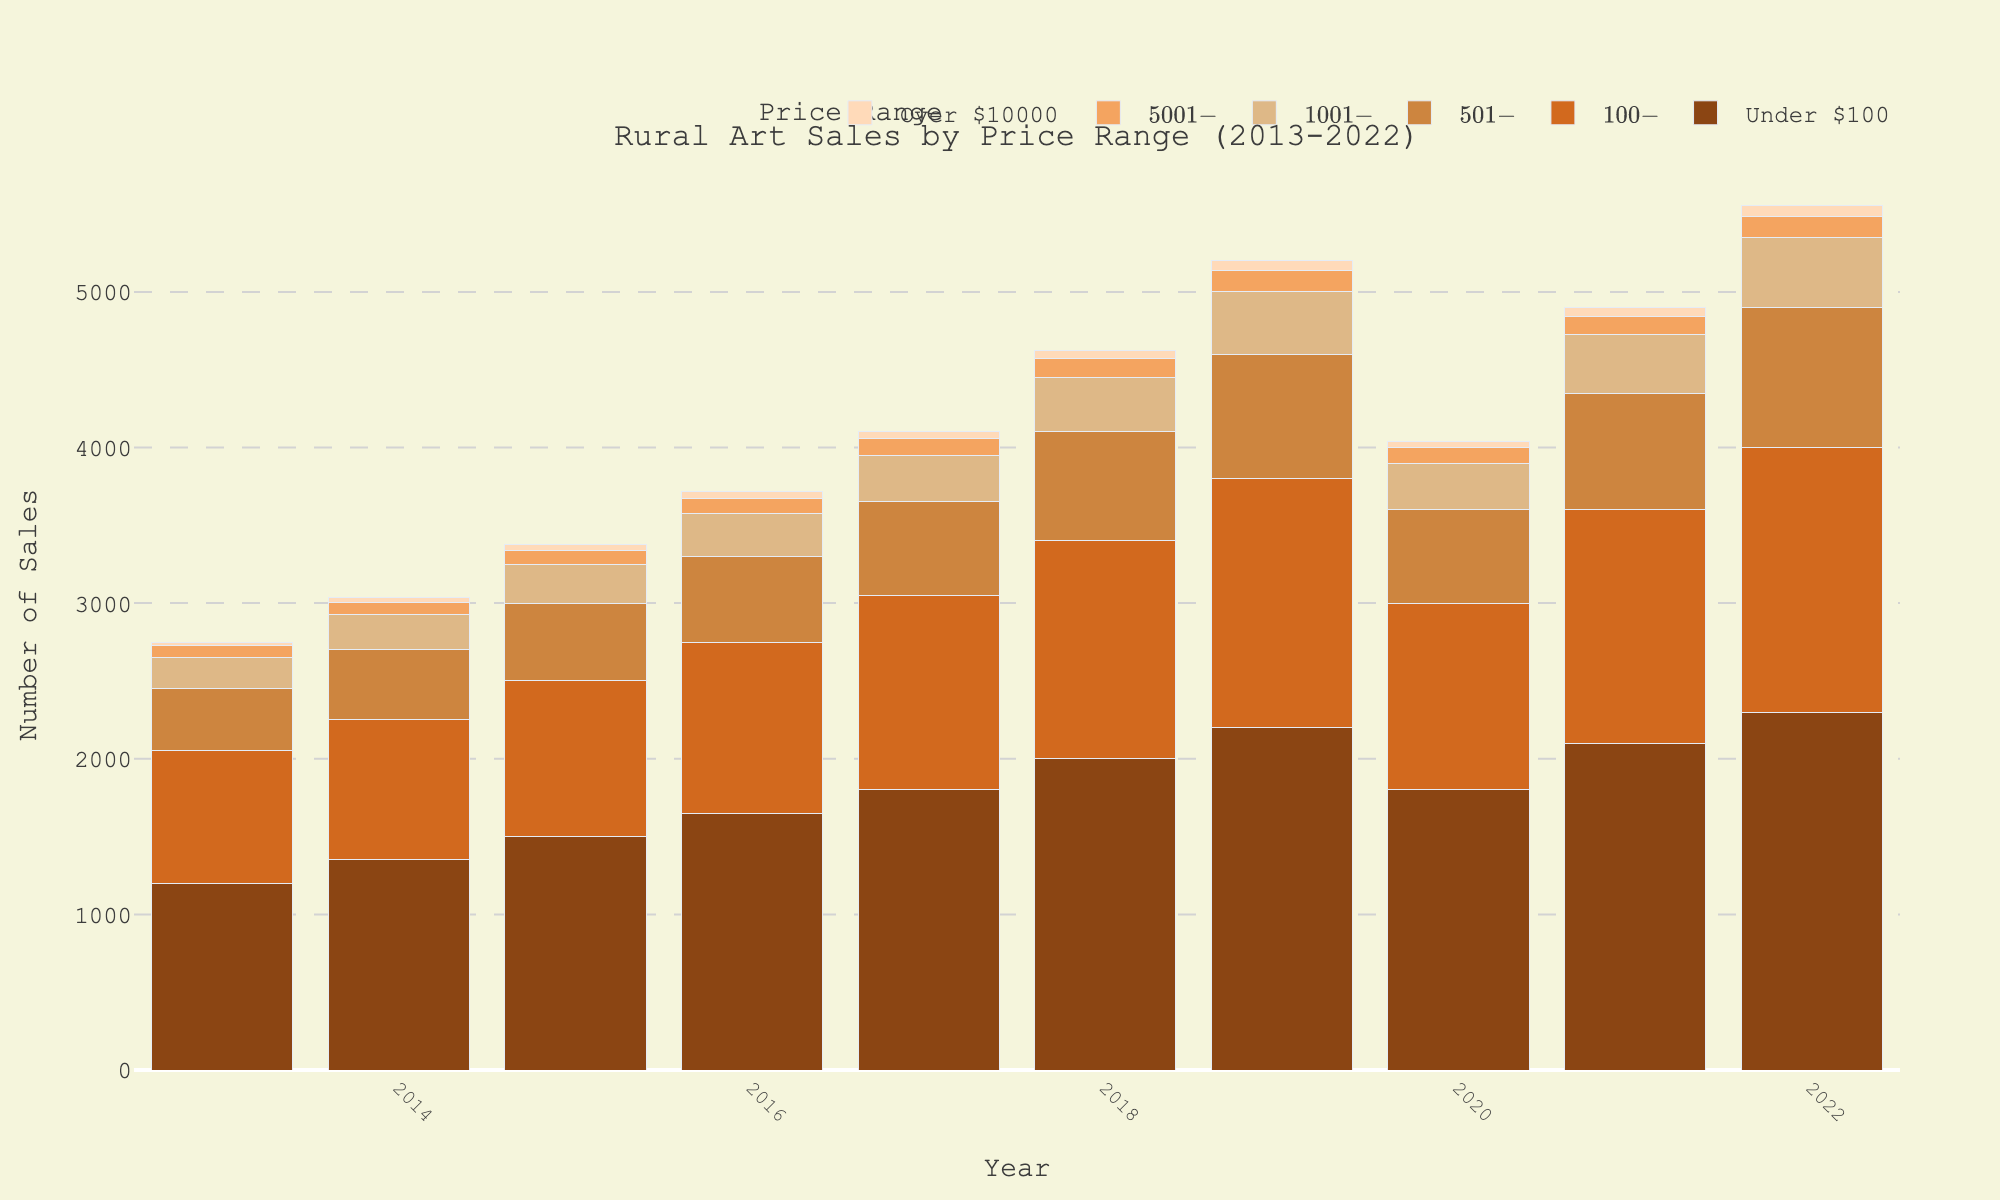What year had the highest sales in the 'Under $100' price range? Look for the bar representing the 'Under $100' price range and identify the tallest bar. The tallest bar in the 'Under $100' category corresponds to the year 2022.
Answer: 2022 Are sales in the '$501-$1000' price range in 2022 higher or lower compared to 2015? Compare the height of the bars for the '$501-$1000' price range in the years 2022 and 2015. The bar in 2022 is taller than in 2015, indicating higher sales.
Answer: Higher What is the average number of sales for the '$100-$500' price range from 2013 to 2022? Sum the number of sales for the '$100-$500' price range across all years and divide by the number of years (10). (850+900+1000+1100+1250+1400+1600+1200+1500+1700)/10 = 1250.
Answer: 1250 Which price range saw the greatest increase in sales from 2013 to 2022? Compare the sales for each price range in 2013 and 2022, and find the price range with the largest difference between these years. 'Under $100' increased by 1100 (2300-1200), which is the greatest increase.
Answer: Under $100 In which year did the '$1001-$5000' price range see its lowest number of sales? Look for the shortest bar for the '$1001-$5000' price range across all years. The shortest bar is in 2013.
Answer: 2013 What is the total number of sales for the 'Over $10000' price range from 2018 to 2022? Sum the number of sales for the 'Over $10000' price range from 2018 to 2022. (50+60+40+55+70) = 275.
Answer: 275 How do sales in the '$5001-$10000' price range in 2020 compare to those in 2021? Compare the height of the bars for the '$5001-$10000' price range in the years 2020 and 2021. The bars are of equal height, indicating that sales numbers are the same.
Answer: Equal What is the total number of sales across all price ranges in 2016? Sum the heights of the bars for all price ranges in the year 2016. (1650+1100+550+275+100+40) = 3715.
Answer: 3715 Which price range consistently had the lowest sales across all years? Identify the price range with the visually lowest bars in each year. 'Over $10000' consistently has the lowest sales.
Answer: Over $10000 Between 2019 and 2022, in the '$501-$1000' price range, were sales in any year higher than the sales in the '$100-$500' price range during the same period? Compare the bars for '$501-$1000' and '$100-$500' for the years 2019-2022. In all comparisons, sales for '$100-$500' are higher than '$501-$1000'.
Answer: No 